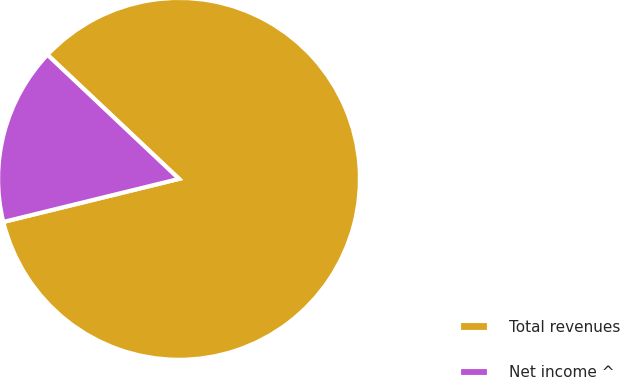<chart> <loc_0><loc_0><loc_500><loc_500><pie_chart><fcel>Total revenues<fcel>Net income ^<nl><fcel>84.14%<fcel>15.86%<nl></chart> 